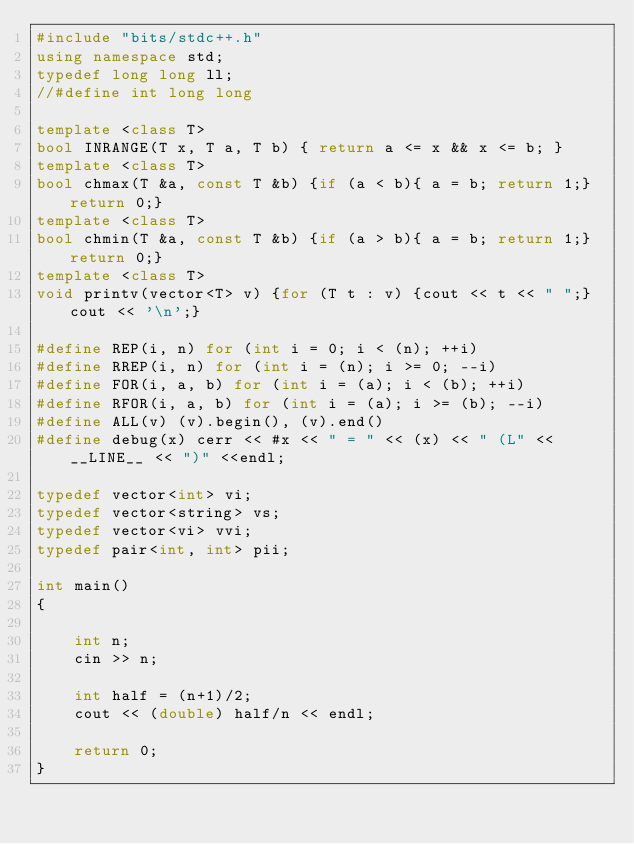<code> <loc_0><loc_0><loc_500><loc_500><_C++_>#include "bits/stdc++.h"
using namespace std;
typedef long long ll;
//#define int long long

template <class T>
bool INRANGE(T x, T a, T b) { return a <= x && x <= b; }
template <class T>
bool chmax(T &a, const T &b) {if (a < b){ a = b; return 1;} return 0;}
template <class T>
bool chmin(T &a, const T &b) {if (a > b){ a = b; return 1;}return 0;}
template <class T>
void printv(vector<T> v) {for (T t : v) {cout << t << " ";}cout << '\n';}

#define REP(i, n) for (int i = 0; i < (n); ++i)
#define RREP(i, n) for (int i = (n); i >= 0; --i)
#define FOR(i, a, b) for (int i = (a); i < (b); ++i)
#define RFOR(i, a, b) for (int i = (a); i >= (b); --i)
#define ALL(v) (v).begin(), (v).end()
#define debug(x) cerr << #x << " = " << (x) << " (L" << __LINE__ << ")" <<endl;

typedef vector<int> vi;
typedef vector<string> vs;
typedef vector<vi> vvi;
typedef pair<int, int> pii;

int main()
{

    int n;
    cin >> n;

    int half = (n+1)/2;
    cout << (double) half/n << endl;

    return 0;
}
</code> 